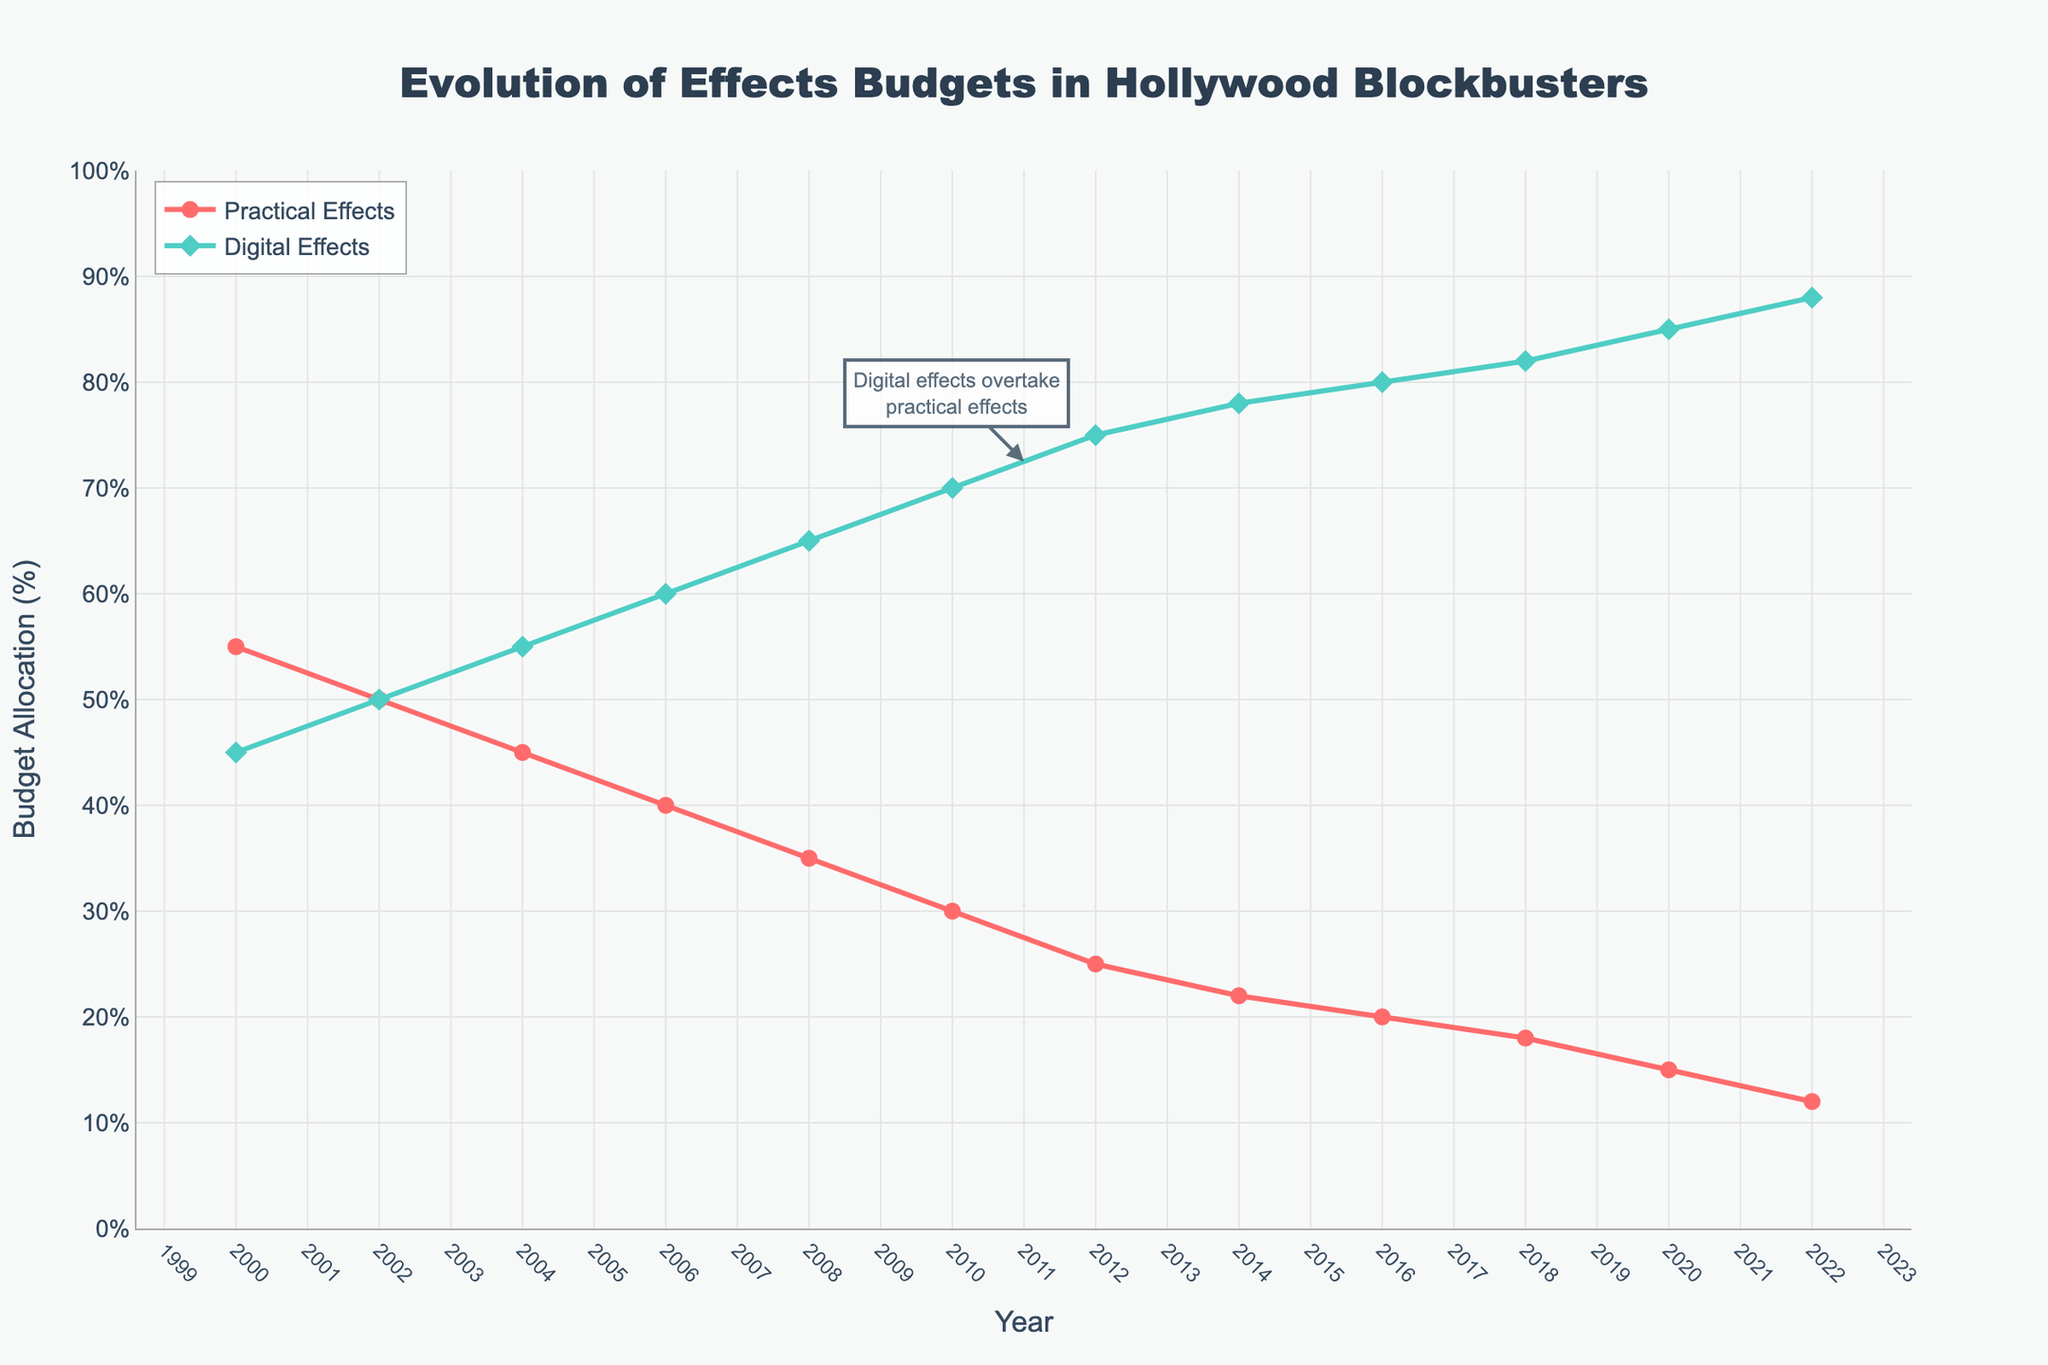what happens to the practical effects budget from 2000 to 2022 The practical effects budget shows a decreasing trend from 55% in 2000 to 12% in 2022. As you move along the timeline, the line representing the practical effects steadily declines, indicating lesser allocation to practical effects over the years.
Answer: It decreases which year marked the first time digital effects budget overtook practical effects budget In 2011, there's an annotation in the chart that points out this event, showing digital effects at 72.5% and practical effects below it.
Answer: 2011 compare the budgets for practical effects and digital effects in 2010 Visual inspection of the chart shows the practical effects budget is at 30% and digital effects budget is at 70% for the year 2010.
Answer: Practical: 30%, Digital: 70% what is the approximate difference in budget allocation between practical and digital effects in 2020 At the year 2020, practical effects have a budget of about 15% and digital effects have a budget of about 85%. Subtracting these two values, the difference is 85% - 15% = 70%.
Answer: 70% can you identify a year where the budgets for practical and digital effects were equal By looking at the converging point on the chart, in 2002, both practical and digital effects budgets are at 50% each.
Answer: 2002 how does the allocation for digital effects change from 2000 to 2010 The digital effects budget increases from 45% in 2000 to 70% in 2010, marked by an upward trend in the line representing digital effects.
Answer: It increases what is the average budget allocation for practical effects during the period from 2010 to 2020 First, note the budget allocations for practical effects from 2010 to 2020: 30%, 25%, 22%, 20%, 18%, and 15%. Summing these values: 30 + 25 + 22 + 20 + 18 + 15 = 130. Divide by the number of years, 6: 130 / 6 ≈ 21.67%.
Answer: 21.67% which budget allocation is consistently higher: practical or digital effects By observing the chart, it is evident that from 2000 to 2008, the practical effects budget is higher, but from 2010 onwards, the digital effects budget is consistently higher.
Answer: Digital Effects describe the trend for digital effects budget from 2004 to 2022 The digital effects budget shows a consistent upward trend starting from 55% in 2004 and reaching 88% by 2022.
Answer: It increases find the year with the biggest gap between practical effects and digital effects budgets The biggest gap appears in 2022 where the practical effects are at 12% and digital effects are at 88%, resulting in a gap of 76%.
Answer: 2022 